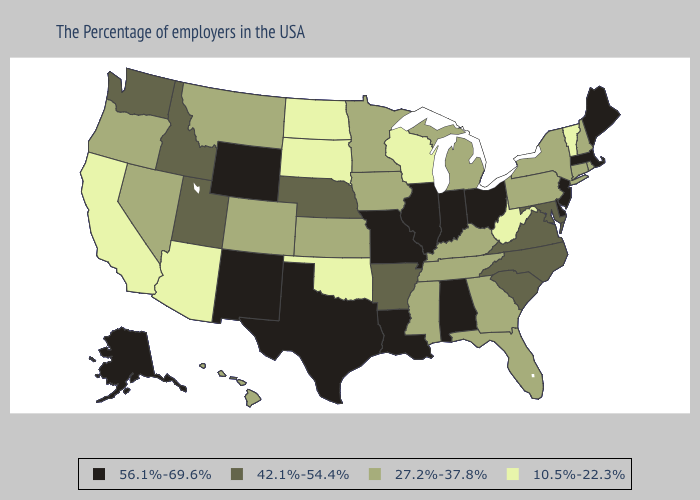What is the lowest value in states that border West Virginia?
Give a very brief answer. 27.2%-37.8%. Does Texas have the highest value in the USA?
Give a very brief answer. Yes. What is the highest value in the USA?
Answer briefly. 56.1%-69.6%. What is the lowest value in states that border Iowa?
Give a very brief answer. 10.5%-22.3%. Does Connecticut have the same value as Michigan?
Write a very short answer. Yes. What is the value of Idaho?
Be succinct. 42.1%-54.4%. Name the states that have a value in the range 27.2%-37.8%?
Concise answer only. Rhode Island, New Hampshire, Connecticut, New York, Pennsylvania, Florida, Georgia, Michigan, Kentucky, Tennessee, Mississippi, Minnesota, Iowa, Kansas, Colorado, Montana, Nevada, Oregon, Hawaii. Does Virginia have the same value as Louisiana?
Give a very brief answer. No. What is the value of Iowa?
Answer briefly. 27.2%-37.8%. Name the states that have a value in the range 56.1%-69.6%?
Give a very brief answer. Maine, Massachusetts, New Jersey, Delaware, Ohio, Indiana, Alabama, Illinois, Louisiana, Missouri, Texas, Wyoming, New Mexico, Alaska. Which states have the lowest value in the Northeast?
Quick response, please. Vermont. What is the lowest value in the USA?
Write a very short answer. 10.5%-22.3%. Which states hav the highest value in the Northeast?
Write a very short answer. Maine, Massachusetts, New Jersey. Is the legend a continuous bar?
Short answer required. No. What is the value of Missouri?
Concise answer only. 56.1%-69.6%. 